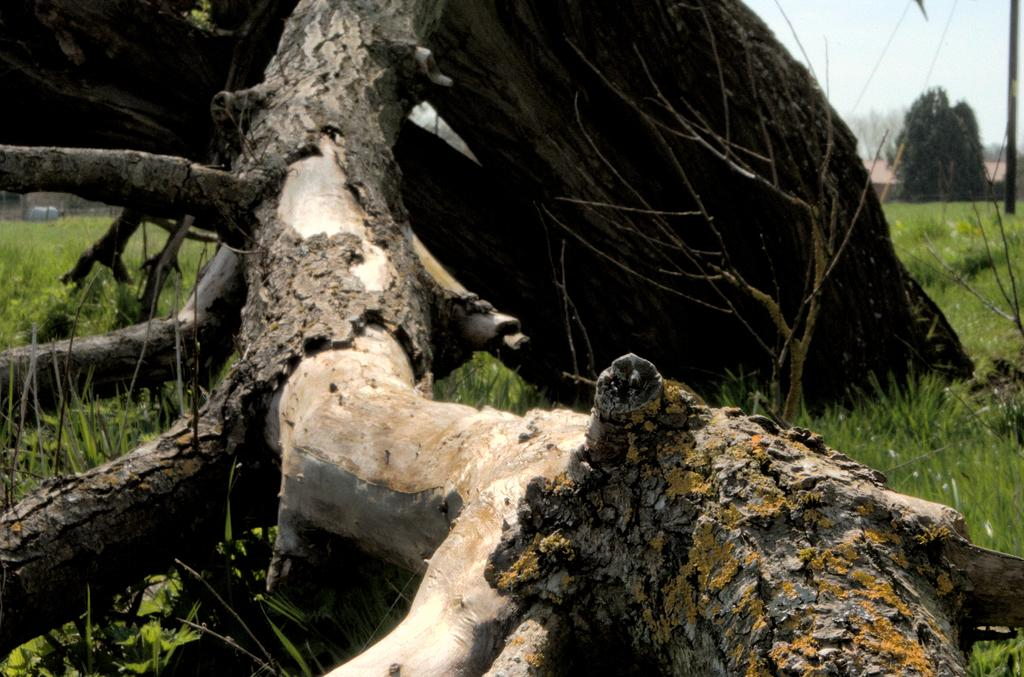What type of natural elements can be seen in the image? There are logs and grass visible in the image. What man-made structure can be seen in the image? There is a pole in the image. What type of vegetation is present in the image? There are trees in the image. What type of building is present in the image? There is a house in the image. What is visible in the background of the image? The sky is visible in the background of the image. Can you tell me how many horses are grazing on the grass in the image? There are no horses present in the image. Where can you find the cherries hanging from the trees in the image? There are no cherries present in the image. What type of pavement is visible in the image? There is no sidewalk or pavement visible in the image. 